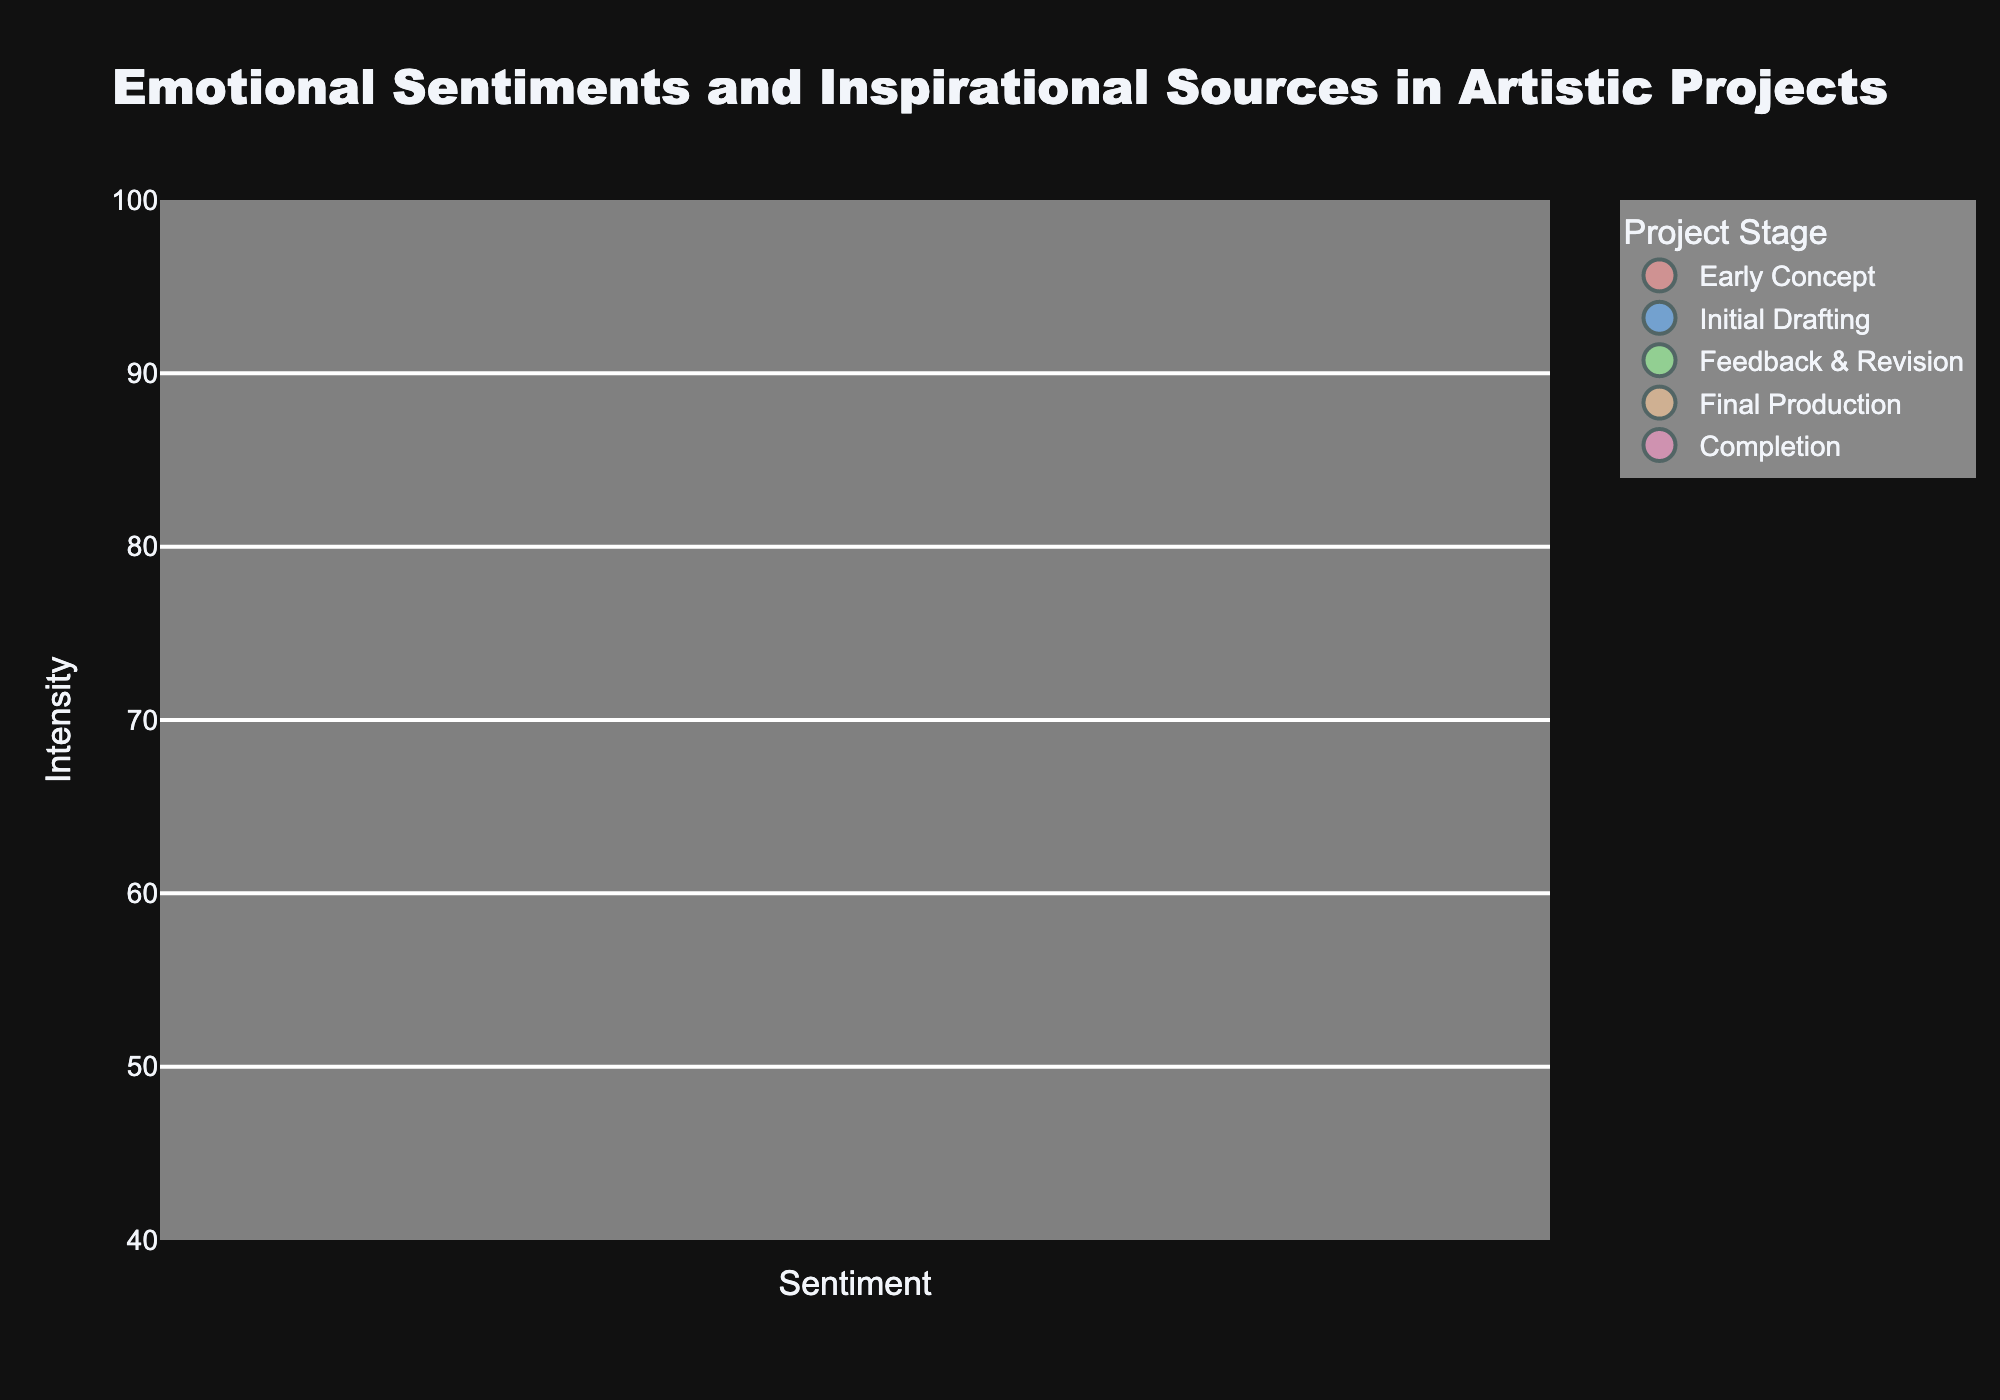What is the title of the bubble chart? The title of the chart is prominently displayed at the top. It reads "Emotional Sentiments and Inspirational Sources in Artistic Projects".
Answer: Emotional Sentiments and Inspirational Sources in Artistic Projects How many different stages are represented in this chart? The legend shows the names of all unique stages present in the plot. Each distinct color and legend label represent a different stage. There are five stages: "Early Concept", "Initial Drafting", "Feedback & Revision", "Final Production", and "Completion".
Answer: 5 Which sentiment has the highest intensity value and what is its corresponding source? By looking at the y-axis and comparing the heights of the bubbles, the highest intensity value bubble occurs at the sentiment "Achievement" with an intensity value of 95. The corresponding source is "Michelangelo".
Answer: Achievement, Michelangelo How does the frequency of "Frustration" during "Feedback & Revision" compare to the frequency of "Patience" during the "Final Production" stage? The size of the bubbles indicates frequency. "Frustration" during "Feedback & Revision" (Salvador Dali) has a frequency of 7. "Patience" during "Final Production" (Claude Monet) has a frequency of 4. By comparing these values, 7 is greater than 4.
Answer: "Frustration" is more frequent than "Patience" by 3 What is the average intensity value of the sentiments in the "Completion" stage? The "Completion" stage has two data points: "Achievement" with an intensity of 95 and "Satisfaction" with an intensity of 85. Summing these values gives 180, and dividing by 2 gives an average of 90.
Answer: 90 Which sentiment in the "Initial Drafting" stage has a higher intensity, and by how much? In the "Initial Drafting" stage, "Creativity" (Yayoi Kusama) has an intensity of 90, and "Passion" (Frida Kahlo) has an intensity of 85. Subtracting 85 from 90 gives a difference of 5.
Answer: Creativity by 5 Are there more sources of inspiration during the "Early Concept" stage or the "Final Production" stage? By counting the bubbles, there are two sources (Pablo Picasso and Leonardo Da Vinci) in the "Early Concept" stage and two sources (Claude Monet and Auguste Rodin) in the "Final Production" stage. Both stages have the same number of sources.
Answer: The same number of sources What are the names of the artists who inspire artistic projects during the "Feedback & Revision" stage? According to the text labels on the bubbles in the "Feedback & Revision" stage, the artists are "Salvador Dali" and "Georges Seurat".
Answer: Salvador Dali and Georges Seurat Which stage has the sentiment with the lowest intensity value, and what is that value? By looking at the y-axis and comparing the lowest bubble, the "Feedback & Revision" stage has the sentiment "Frustration" with the lowest intensity value of 50.
Answer: Feedback & Revision, 50 